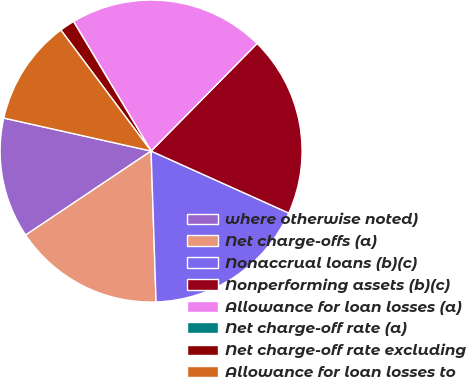Convert chart. <chart><loc_0><loc_0><loc_500><loc_500><pie_chart><fcel>where otherwise noted)<fcel>Net charge-offs (a)<fcel>Nonaccrual loans (b)(c)<fcel>Nonperforming assets (b)(c)<fcel>Allowance for loan losses (a)<fcel>Net charge-off rate (a)<fcel>Net charge-off rate excluding<fcel>Allowance for loan losses to<nl><fcel>12.9%<fcel>16.13%<fcel>17.74%<fcel>19.35%<fcel>20.97%<fcel>0.0%<fcel>1.61%<fcel>11.29%<nl></chart> 